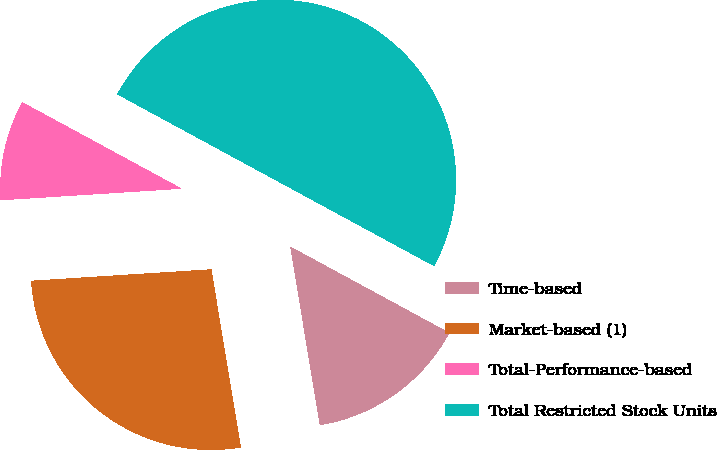<chart> <loc_0><loc_0><loc_500><loc_500><pie_chart><fcel>Time-based<fcel>Market-based (1)<fcel>Total-Performance-based<fcel>Total Restricted Stock Units<nl><fcel>14.48%<fcel>26.6%<fcel>8.92%<fcel>50.0%<nl></chart> 